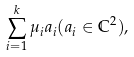<formula> <loc_0><loc_0><loc_500><loc_500>\sum _ { i = 1 } ^ { k } \mu _ { i } a _ { i } ( a _ { i } \in \mathbb { C } ^ { 2 } ) ,</formula> 